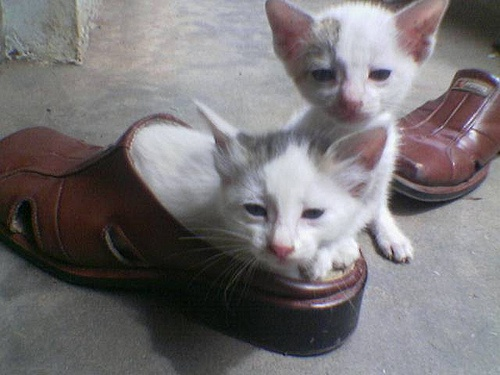Describe the objects in this image and their specific colors. I can see a cat in gray, lightgray, and darkgray tones in this image. 